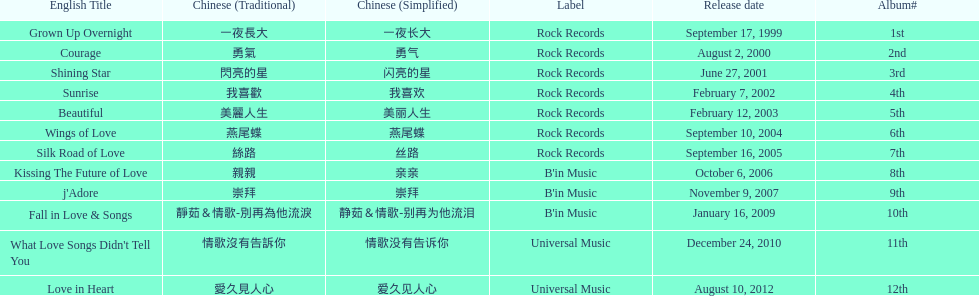Which song is listed first in the table? Grown Up Overnight. 